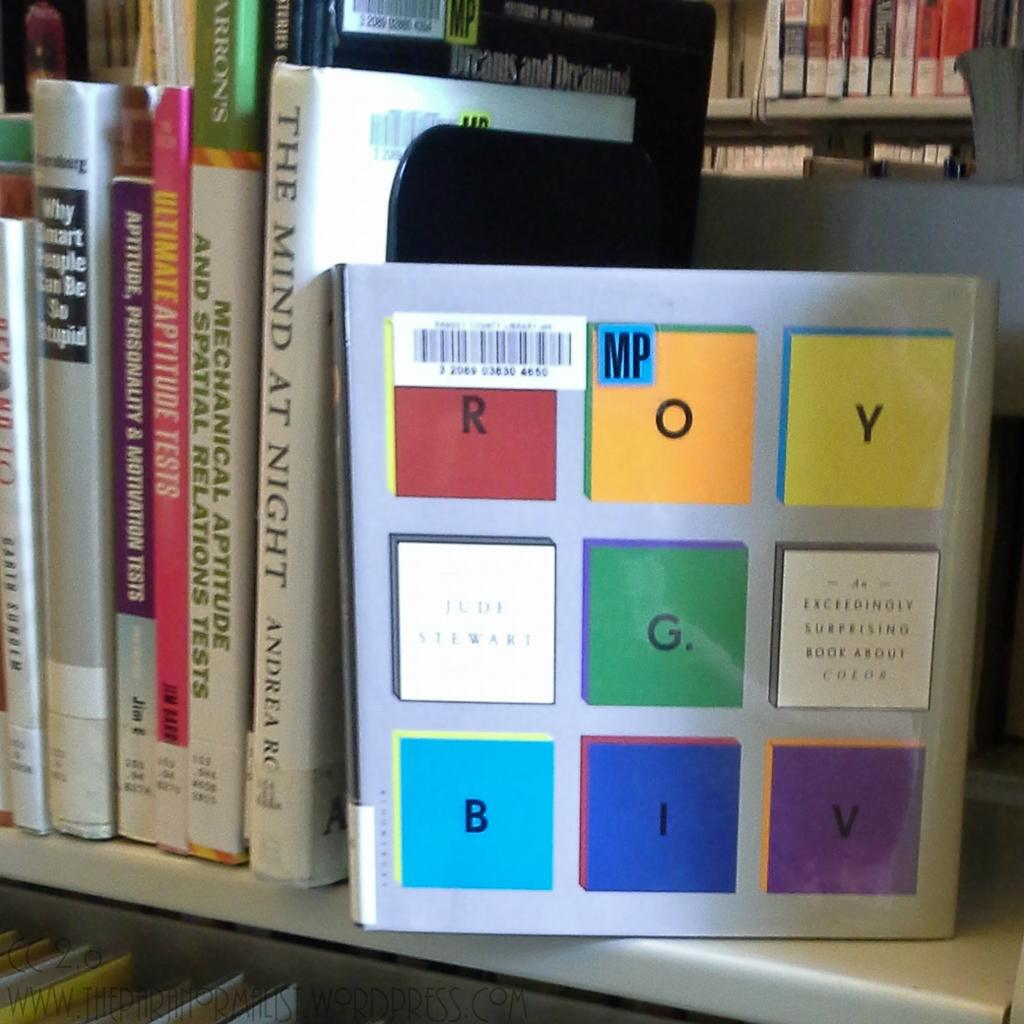<image>
Provide a brief description of the given image. A book shelf full of books and one is called The Mind at Night. 